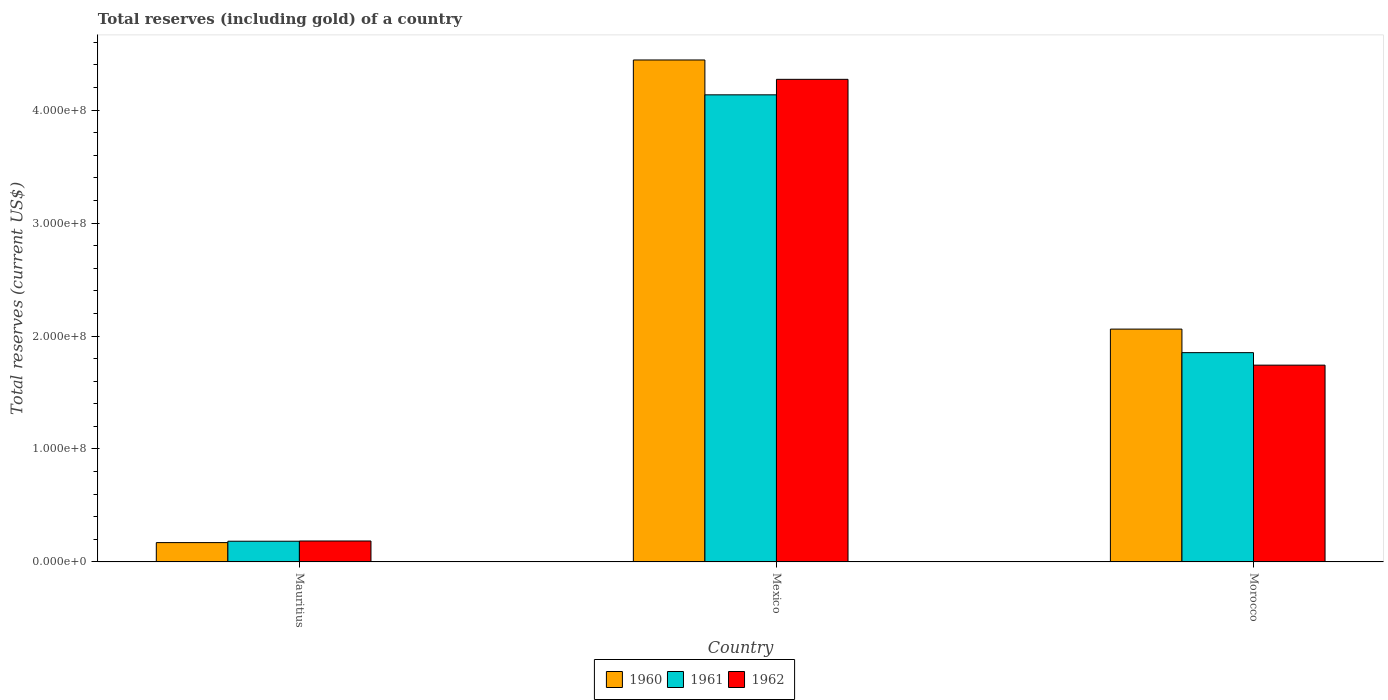How many different coloured bars are there?
Provide a succinct answer. 3. Are the number of bars on each tick of the X-axis equal?
Ensure brevity in your answer.  Yes. How many bars are there on the 1st tick from the left?
Keep it short and to the point. 3. How many bars are there on the 1st tick from the right?
Ensure brevity in your answer.  3. What is the total reserves (including gold) in 1960 in Mauritius?
Provide a succinct answer. 1.71e+07. Across all countries, what is the maximum total reserves (including gold) in 1962?
Your response must be concise. 4.27e+08. Across all countries, what is the minimum total reserves (including gold) in 1960?
Ensure brevity in your answer.  1.71e+07. In which country was the total reserves (including gold) in 1962 minimum?
Give a very brief answer. Mauritius. What is the total total reserves (including gold) in 1962 in the graph?
Your answer should be very brief. 6.20e+08. What is the difference between the total reserves (including gold) in 1960 in Mauritius and that in Morocco?
Your answer should be compact. -1.89e+08. What is the difference between the total reserves (including gold) in 1961 in Mexico and the total reserves (including gold) in 1960 in Morocco?
Provide a succinct answer. 2.07e+08. What is the average total reserves (including gold) in 1962 per country?
Provide a succinct answer. 2.07e+08. What is the difference between the total reserves (including gold) of/in 1962 and total reserves (including gold) of/in 1961 in Morocco?
Offer a very short reply. -1.11e+07. What is the ratio of the total reserves (including gold) in 1961 in Mauritius to that in Mexico?
Provide a short and direct response. 0.04. Is the total reserves (including gold) in 1962 in Mexico less than that in Morocco?
Your answer should be compact. No. What is the difference between the highest and the second highest total reserves (including gold) in 1961?
Give a very brief answer. 2.28e+08. What is the difference between the highest and the lowest total reserves (including gold) in 1960?
Give a very brief answer. 4.27e+08. Is the sum of the total reserves (including gold) in 1962 in Mauritius and Mexico greater than the maximum total reserves (including gold) in 1960 across all countries?
Provide a short and direct response. Yes. What does the 1st bar from the left in Mauritius represents?
Your response must be concise. 1960. Is it the case that in every country, the sum of the total reserves (including gold) in 1960 and total reserves (including gold) in 1961 is greater than the total reserves (including gold) in 1962?
Ensure brevity in your answer.  Yes. Are all the bars in the graph horizontal?
Provide a short and direct response. No. How many countries are there in the graph?
Ensure brevity in your answer.  3. What is the difference between two consecutive major ticks on the Y-axis?
Your answer should be very brief. 1.00e+08. Are the values on the major ticks of Y-axis written in scientific E-notation?
Offer a very short reply. Yes. Does the graph contain any zero values?
Ensure brevity in your answer.  No. Does the graph contain grids?
Your answer should be very brief. No. Where does the legend appear in the graph?
Provide a short and direct response. Bottom center. How many legend labels are there?
Your response must be concise. 3. How are the legend labels stacked?
Your answer should be compact. Horizontal. What is the title of the graph?
Your answer should be very brief. Total reserves (including gold) of a country. Does "1966" appear as one of the legend labels in the graph?
Your response must be concise. No. What is the label or title of the Y-axis?
Make the answer very short. Total reserves (current US$). What is the Total reserves (current US$) of 1960 in Mauritius?
Offer a terse response. 1.71e+07. What is the Total reserves (current US$) in 1961 in Mauritius?
Give a very brief answer. 1.83e+07. What is the Total reserves (current US$) in 1962 in Mauritius?
Offer a very short reply. 1.86e+07. What is the Total reserves (current US$) of 1960 in Mexico?
Offer a terse response. 4.44e+08. What is the Total reserves (current US$) in 1961 in Mexico?
Keep it short and to the point. 4.13e+08. What is the Total reserves (current US$) of 1962 in Mexico?
Your answer should be very brief. 4.27e+08. What is the Total reserves (current US$) of 1960 in Morocco?
Offer a terse response. 2.06e+08. What is the Total reserves (current US$) of 1961 in Morocco?
Provide a succinct answer. 1.85e+08. What is the Total reserves (current US$) in 1962 in Morocco?
Provide a succinct answer. 1.74e+08. Across all countries, what is the maximum Total reserves (current US$) of 1960?
Your response must be concise. 4.44e+08. Across all countries, what is the maximum Total reserves (current US$) of 1961?
Offer a very short reply. 4.13e+08. Across all countries, what is the maximum Total reserves (current US$) in 1962?
Give a very brief answer. 4.27e+08. Across all countries, what is the minimum Total reserves (current US$) in 1960?
Give a very brief answer. 1.71e+07. Across all countries, what is the minimum Total reserves (current US$) of 1961?
Your answer should be very brief. 1.83e+07. Across all countries, what is the minimum Total reserves (current US$) in 1962?
Provide a succinct answer. 1.86e+07. What is the total Total reserves (current US$) in 1960 in the graph?
Offer a very short reply. 6.68e+08. What is the total Total reserves (current US$) in 1961 in the graph?
Provide a short and direct response. 6.17e+08. What is the total Total reserves (current US$) of 1962 in the graph?
Offer a terse response. 6.20e+08. What is the difference between the Total reserves (current US$) of 1960 in Mauritius and that in Mexico?
Provide a short and direct response. -4.27e+08. What is the difference between the Total reserves (current US$) of 1961 in Mauritius and that in Mexico?
Keep it short and to the point. -3.95e+08. What is the difference between the Total reserves (current US$) of 1962 in Mauritius and that in Mexico?
Your response must be concise. -4.09e+08. What is the difference between the Total reserves (current US$) in 1960 in Mauritius and that in Morocco?
Offer a very short reply. -1.89e+08. What is the difference between the Total reserves (current US$) in 1961 in Mauritius and that in Morocco?
Your response must be concise. -1.67e+08. What is the difference between the Total reserves (current US$) in 1962 in Mauritius and that in Morocco?
Provide a short and direct response. -1.56e+08. What is the difference between the Total reserves (current US$) of 1960 in Mexico and that in Morocco?
Give a very brief answer. 2.38e+08. What is the difference between the Total reserves (current US$) in 1961 in Mexico and that in Morocco?
Make the answer very short. 2.28e+08. What is the difference between the Total reserves (current US$) in 1962 in Mexico and that in Morocco?
Your answer should be compact. 2.53e+08. What is the difference between the Total reserves (current US$) in 1960 in Mauritius and the Total reserves (current US$) in 1961 in Mexico?
Give a very brief answer. -3.96e+08. What is the difference between the Total reserves (current US$) in 1960 in Mauritius and the Total reserves (current US$) in 1962 in Mexico?
Keep it short and to the point. -4.10e+08. What is the difference between the Total reserves (current US$) in 1961 in Mauritius and the Total reserves (current US$) in 1962 in Mexico?
Offer a very short reply. -4.09e+08. What is the difference between the Total reserves (current US$) of 1960 in Mauritius and the Total reserves (current US$) of 1961 in Morocco?
Offer a very short reply. -1.68e+08. What is the difference between the Total reserves (current US$) in 1960 in Mauritius and the Total reserves (current US$) in 1962 in Morocco?
Your answer should be compact. -1.57e+08. What is the difference between the Total reserves (current US$) of 1961 in Mauritius and the Total reserves (current US$) of 1962 in Morocco?
Provide a short and direct response. -1.56e+08. What is the difference between the Total reserves (current US$) of 1960 in Mexico and the Total reserves (current US$) of 1961 in Morocco?
Ensure brevity in your answer.  2.59e+08. What is the difference between the Total reserves (current US$) in 1960 in Mexico and the Total reserves (current US$) in 1962 in Morocco?
Ensure brevity in your answer.  2.70e+08. What is the difference between the Total reserves (current US$) of 1961 in Mexico and the Total reserves (current US$) of 1962 in Morocco?
Provide a short and direct response. 2.39e+08. What is the average Total reserves (current US$) in 1960 per country?
Give a very brief answer. 2.23e+08. What is the average Total reserves (current US$) of 1961 per country?
Provide a succinct answer. 2.06e+08. What is the average Total reserves (current US$) of 1962 per country?
Provide a short and direct response. 2.07e+08. What is the difference between the Total reserves (current US$) in 1960 and Total reserves (current US$) in 1961 in Mauritius?
Keep it short and to the point. -1.22e+06. What is the difference between the Total reserves (current US$) of 1960 and Total reserves (current US$) of 1962 in Mauritius?
Provide a short and direct response. -1.43e+06. What is the difference between the Total reserves (current US$) of 1960 and Total reserves (current US$) of 1961 in Mexico?
Your answer should be compact. 3.09e+07. What is the difference between the Total reserves (current US$) of 1960 and Total reserves (current US$) of 1962 in Mexico?
Give a very brief answer. 1.71e+07. What is the difference between the Total reserves (current US$) in 1961 and Total reserves (current US$) in 1962 in Mexico?
Provide a short and direct response. -1.37e+07. What is the difference between the Total reserves (current US$) of 1960 and Total reserves (current US$) of 1961 in Morocco?
Provide a succinct answer. 2.08e+07. What is the difference between the Total reserves (current US$) of 1960 and Total reserves (current US$) of 1962 in Morocco?
Keep it short and to the point. 3.19e+07. What is the difference between the Total reserves (current US$) in 1961 and Total reserves (current US$) in 1962 in Morocco?
Your answer should be compact. 1.11e+07. What is the ratio of the Total reserves (current US$) of 1960 in Mauritius to that in Mexico?
Your response must be concise. 0.04. What is the ratio of the Total reserves (current US$) of 1961 in Mauritius to that in Mexico?
Your answer should be compact. 0.04. What is the ratio of the Total reserves (current US$) of 1962 in Mauritius to that in Mexico?
Make the answer very short. 0.04. What is the ratio of the Total reserves (current US$) of 1960 in Mauritius to that in Morocco?
Make the answer very short. 0.08. What is the ratio of the Total reserves (current US$) of 1961 in Mauritius to that in Morocco?
Provide a succinct answer. 0.1. What is the ratio of the Total reserves (current US$) in 1962 in Mauritius to that in Morocco?
Your response must be concise. 0.11. What is the ratio of the Total reserves (current US$) of 1960 in Mexico to that in Morocco?
Offer a terse response. 2.16. What is the ratio of the Total reserves (current US$) in 1961 in Mexico to that in Morocco?
Provide a succinct answer. 2.23. What is the ratio of the Total reserves (current US$) in 1962 in Mexico to that in Morocco?
Provide a succinct answer. 2.45. What is the difference between the highest and the second highest Total reserves (current US$) in 1960?
Provide a succinct answer. 2.38e+08. What is the difference between the highest and the second highest Total reserves (current US$) of 1961?
Make the answer very short. 2.28e+08. What is the difference between the highest and the second highest Total reserves (current US$) of 1962?
Keep it short and to the point. 2.53e+08. What is the difference between the highest and the lowest Total reserves (current US$) in 1960?
Your answer should be compact. 4.27e+08. What is the difference between the highest and the lowest Total reserves (current US$) of 1961?
Provide a short and direct response. 3.95e+08. What is the difference between the highest and the lowest Total reserves (current US$) of 1962?
Provide a short and direct response. 4.09e+08. 